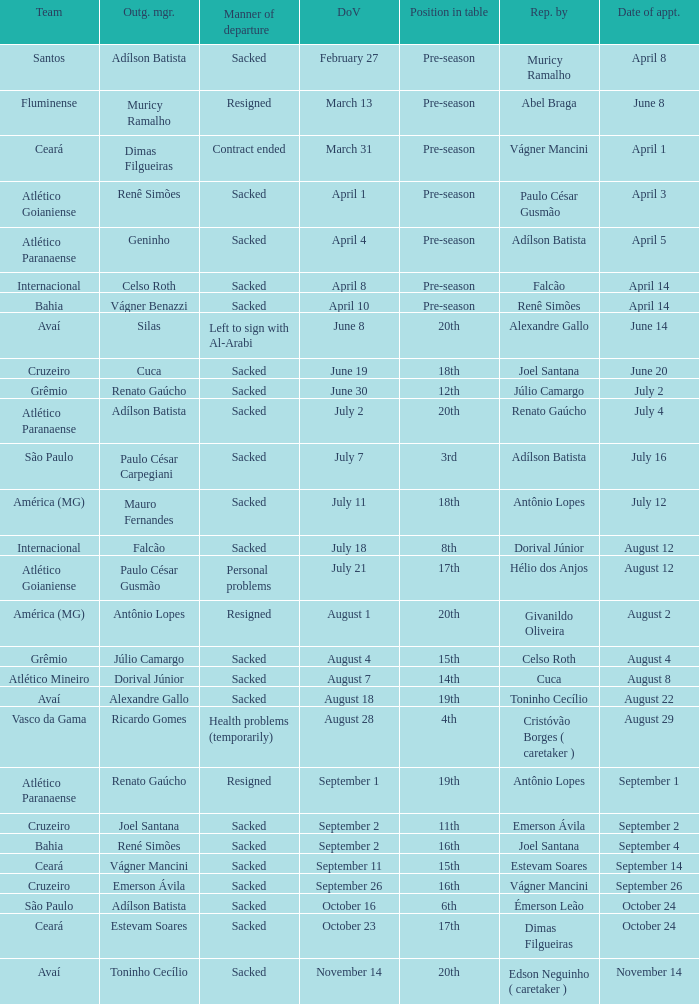Could you parse the entire table as a dict? {'header': ['Team', 'Outg. mgr.', 'Manner of departure', 'DoV', 'Position in table', 'Rep. by', 'Date of appt.'], 'rows': [['Santos', 'Adílson Batista', 'Sacked', 'February 27', 'Pre-season', 'Muricy Ramalho', 'April 8'], ['Fluminense', 'Muricy Ramalho', 'Resigned', 'March 13', 'Pre-season', 'Abel Braga', 'June 8'], ['Ceará', 'Dimas Filgueiras', 'Contract ended', 'March 31', 'Pre-season', 'Vágner Mancini', 'April 1'], ['Atlético Goianiense', 'Renê Simões', 'Sacked', 'April 1', 'Pre-season', 'Paulo César Gusmão', 'April 3'], ['Atlético Paranaense', 'Geninho', 'Sacked', 'April 4', 'Pre-season', 'Adílson Batista', 'April 5'], ['Internacional', 'Celso Roth', 'Sacked', 'April 8', 'Pre-season', 'Falcão', 'April 14'], ['Bahia', 'Vágner Benazzi', 'Sacked', 'April 10', 'Pre-season', 'Renê Simões', 'April 14'], ['Avaí', 'Silas', 'Left to sign with Al-Arabi', 'June 8', '20th', 'Alexandre Gallo', 'June 14'], ['Cruzeiro', 'Cuca', 'Sacked', 'June 19', '18th', 'Joel Santana', 'June 20'], ['Grêmio', 'Renato Gaúcho', 'Sacked', 'June 30', '12th', 'Júlio Camargo', 'July 2'], ['Atlético Paranaense', 'Adílson Batista', 'Sacked', 'July 2', '20th', 'Renato Gaúcho', 'July 4'], ['São Paulo', 'Paulo César Carpegiani', 'Sacked', 'July 7', '3rd', 'Adílson Batista', 'July 16'], ['América (MG)', 'Mauro Fernandes', 'Sacked', 'July 11', '18th', 'Antônio Lopes', 'July 12'], ['Internacional', 'Falcão', 'Sacked', 'July 18', '8th', 'Dorival Júnior', 'August 12'], ['Atlético Goianiense', 'Paulo César Gusmão', 'Personal problems', 'July 21', '17th', 'Hélio dos Anjos', 'August 12'], ['América (MG)', 'Antônio Lopes', 'Resigned', 'August 1', '20th', 'Givanildo Oliveira', 'August 2'], ['Grêmio', 'Júlio Camargo', 'Sacked', 'August 4', '15th', 'Celso Roth', 'August 4'], ['Atlético Mineiro', 'Dorival Júnior', 'Sacked', 'August 7', '14th', 'Cuca', 'August 8'], ['Avaí', 'Alexandre Gallo', 'Sacked', 'August 18', '19th', 'Toninho Cecílio', 'August 22'], ['Vasco da Gama', 'Ricardo Gomes', 'Health problems (temporarily)', 'August 28', '4th', 'Cristóvão Borges ( caretaker )', 'August 29'], ['Atlético Paranaense', 'Renato Gaúcho', 'Resigned', 'September 1', '19th', 'Antônio Lopes', 'September 1'], ['Cruzeiro', 'Joel Santana', 'Sacked', 'September 2', '11th', 'Emerson Ávila', 'September 2'], ['Bahia', 'René Simões', 'Sacked', 'September 2', '16th', 'Joel Santana', 'September 4'], ['Ceará', 'Vágner Mancini', 'Sacked', 'September 11', '15th', 'Estevam Soares', 'September 14'], ['Cruzeiro', 'Emerson Ávila', 'Sacked', 'September 26', '16th', 'Vágner Mancini', 'September 26'], ['São Paulo', 'Adílson Batista', 'Sacked', 'October 16', '6th', 'Émerson Leão', 'October 24'], ['Ceará', 'Estevam Soares', 'Sacked', 'October 23', '17th', 'Dimas Filgueiras', 'October 24'], ['Avaí', 'Toninho Cecílio', 'Sacked', 'November 14', '20th', 'Edson Neguinho ( caretaker )', 'November 14']]} Who was the new Santos manager? Muricy Ramalho. 